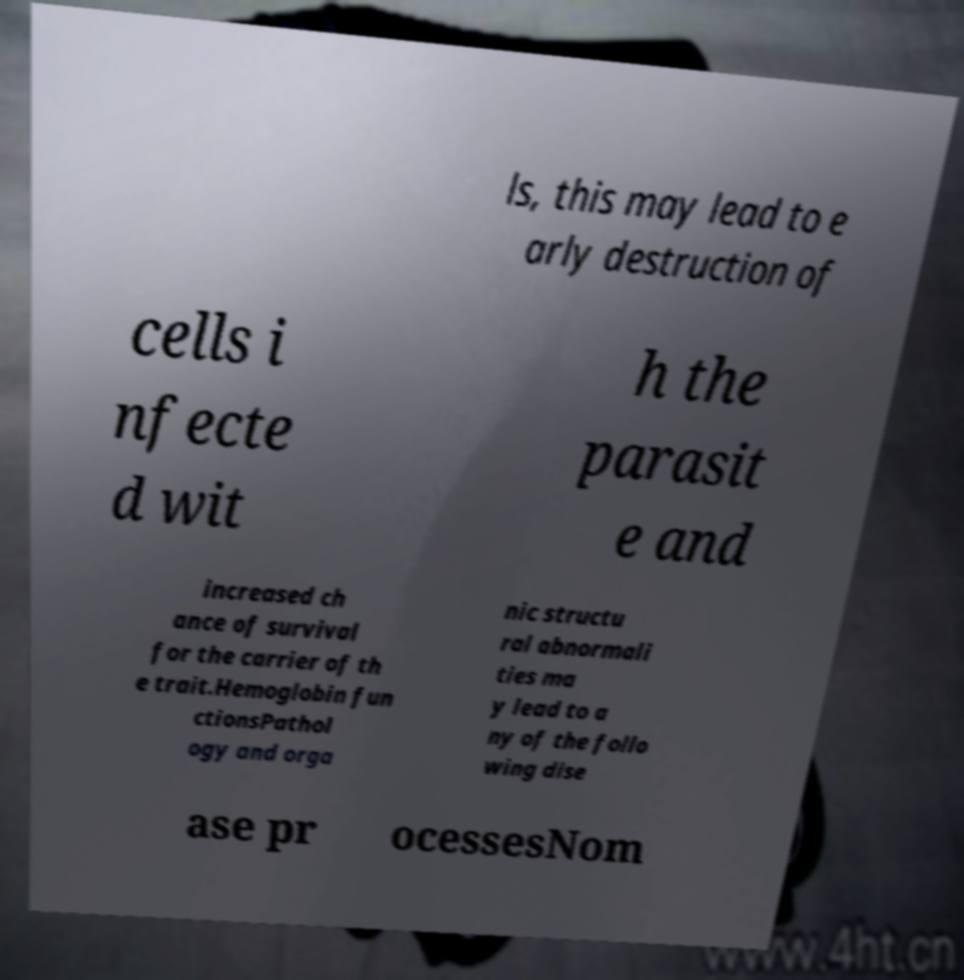Could you assist in decoding the text presented in this image and type it out clearly? ls, this may lead to e arly destruction of cells i nfecte d wit h the parasit e and increased ch ance of survival for the carrier of th e trait.Hemoglobin fun ctionsPathol ogy and orga nic structu ral abnormali ties ma y lead to a ny of the follo wing dise ase pr ocessesNom 